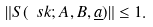<formula> <loc_0><loc_0><loc_500><loc_500>\| S ( \ s k ; A , B , \underline { a } ) \| \leq 1 .</formula> 